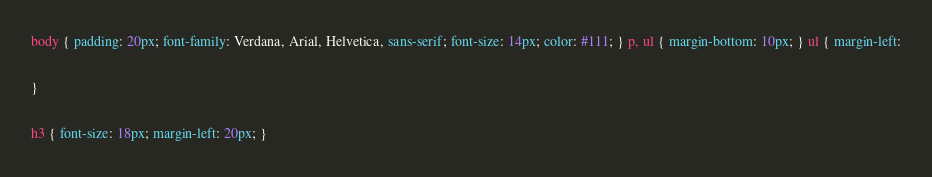Convert code to text. <code><loc_0><loc_0><loc_500><loc_500><_CSS_>body { padding: 20px; font-family: Verdana, Arial, Helvetica, sans-serif; font-size: 14px; color: #111; } p, ul { margin-bottom: 10px; } ul { margin-left:

}

h3 { font-size: 18px; margin-left: 20px; }



</code> 